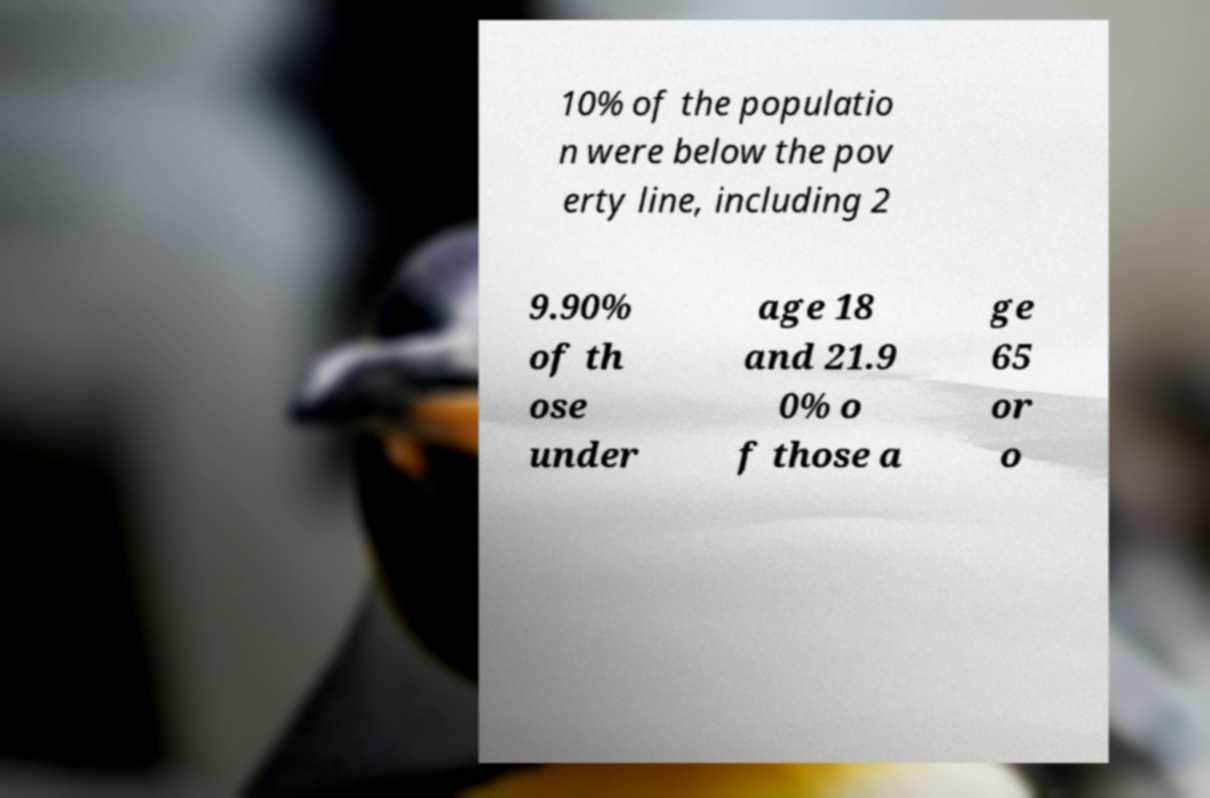Could you assist in decoding the text presented in this image and type it out clearly? 10% of the populatio n were below the pov erty line, including 2 9.90% of th ose under age 18 and 21.9 0% o f those a ge 65 or o 